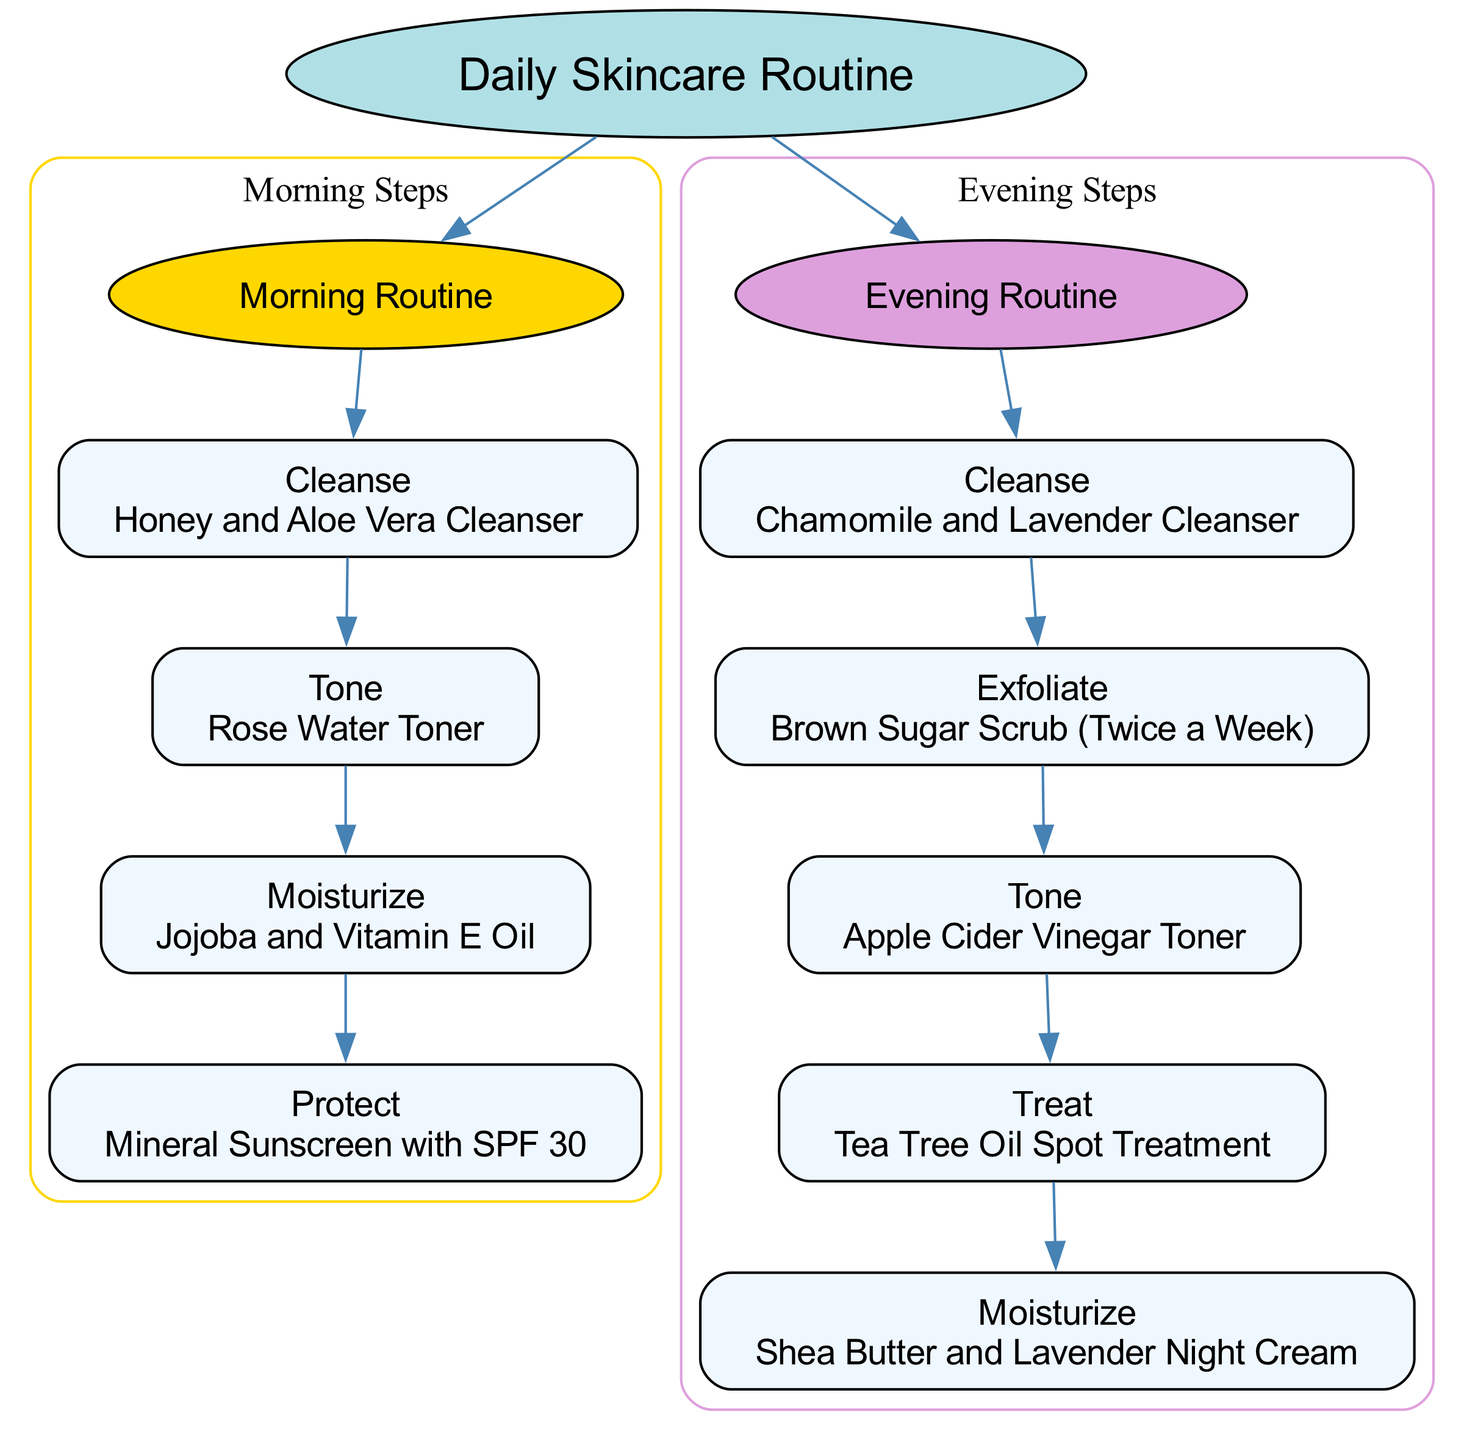What is the first step in the morning routine? The diagram lists the steps in the morning routine, beginning with Step 1, which is "Cleanse" using "Honey and Aloe Vera Cleanser."
Answer: Cleanse How many steps are in the evening routine? In the diagram, the evening routine lists a total of 5 steps, which include Cleanse, Exfoliate, Tone, Treat, and Moisturize.
Answer: 5 What product is used for toning in the morning? Referring to the morning routine section of the diagram, the product used for toning is "Rose Water Toner."
Answer: Rose Water Toner Which product in the evening routine is specifically for treating blemishes? Analyzing the steps in the evening routine, the product designated for treating blemishes is "Tea Tree Oil Spot Treatment."
Answer: Tea Tree Oil Spot Treatment What is the last step in the morning routine? Within the morning routine as shown in the diagram, the last step (Step 4) is "Protect" using "Mineral Sunscreen with SPF 30."
Answer: Protect What do you use to exfoliate, and how often? In examining the evening routine, the product used for exfoliating is "Brown Sugar Scrub," and it is indicated for use "Twice a Week."
Answer: Brown Sugar Scrub (Twice a Week) Which routine includes "Shea Butter and Lavender Night Cream"? The diagram outlines that "Shea Butter and Lavender Night Cream" is part of the evening routine as the last step (Step 5).
Answer: Evening Routine How many nodes are there in the morning section? By reviewing the diagram, the morning routine contains 4 nodes corresponding to the 4 steps: Cleanse, Tone, Moisturize, and Protect.
Answer: 4 Which tonic is used in the evening? Referring to the evening routine in the diagram, the tonic used is "Apple Cider Vinegar Toner."
Answer: Apple Cider Vinegar Toner 